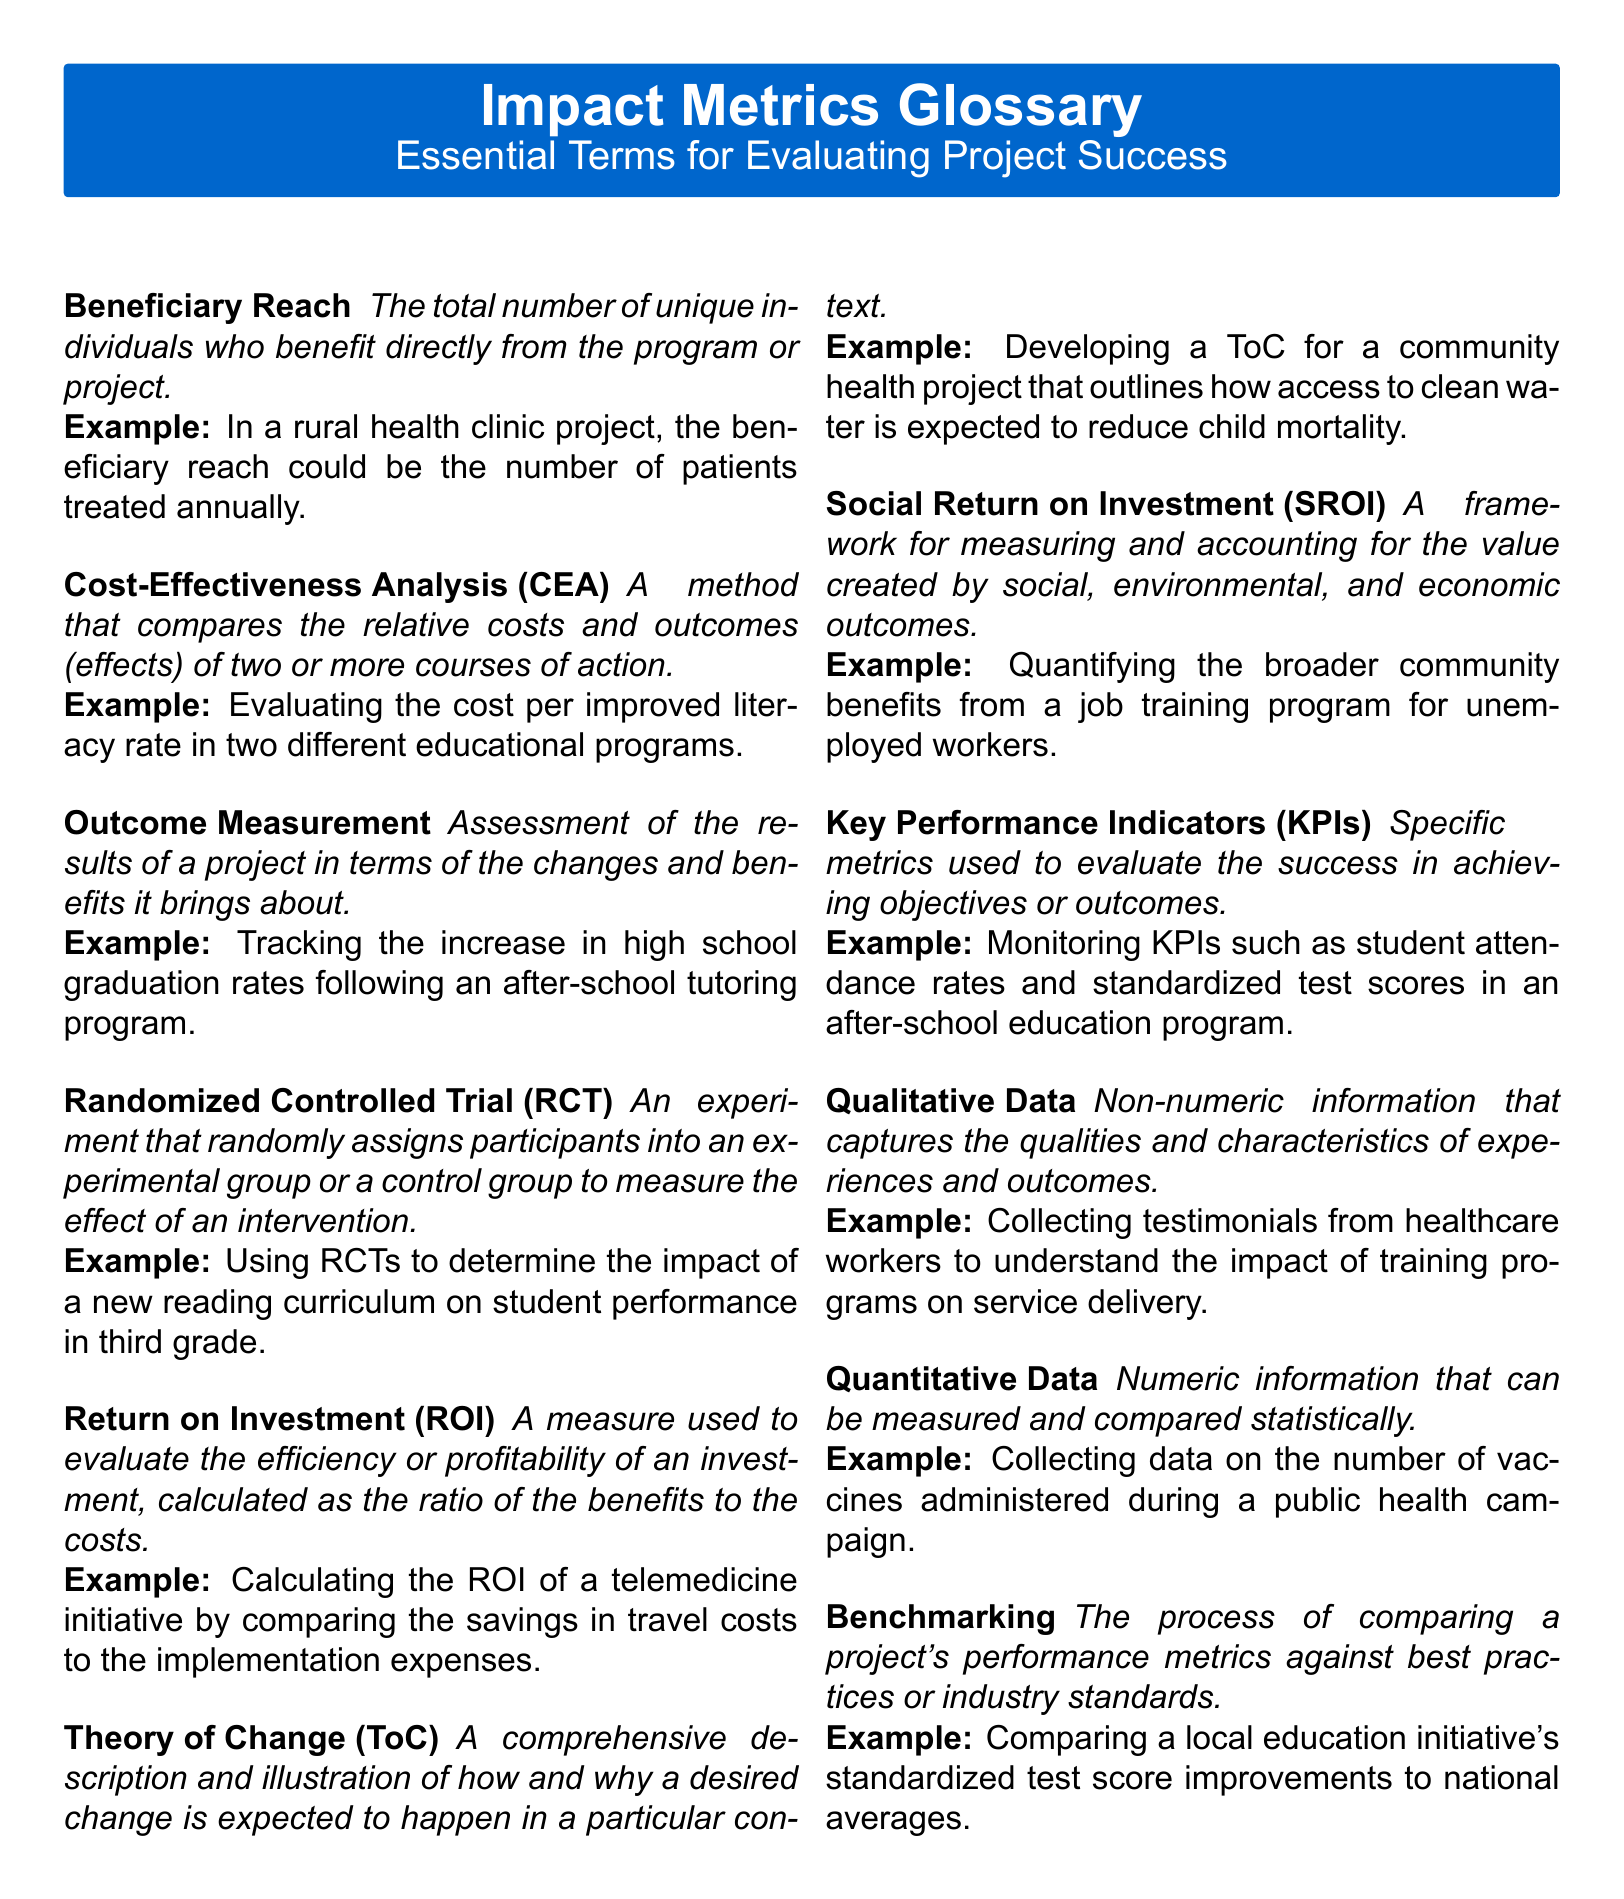What is the definition of Beneficiary Reach? Beneficiary Reach is defined as the total number of unique individuals who benefit directly from the program or project.
Answer: The total number of unique individuals who benefit directly from the program or project What does Cost-Effectiveness Analysis compare? Cost-Effectiveness Analysis compares the relative costs and outcomes of two or more courses of action.
Answer: The relative costs and outcomes of two or more courses of action What is an example of Outcome Measurement? An example provided is tracking the increase in high school graduation rates following an after-school tutoring program.
Answer: Tracking the increase in high school graduation rates following an after-school tutoring program What type of trial is a Randomized Controlled Trial? A Randomized Controlled Trial is a type of experiment that randomly assigns participants into an experimental group or a control group.
Answer: An experiment that randomly assigns participants into an experimental group or a control group What does ROI stand for? ROI stands for Return on Investment.
Answer: Return on Investment What is the purpose of Theory of Change? The purpose of Theory of Change is to illustrate how and why a desired change is expected to happen in a particular context.
Answer: To illustrate how and why a desired change is expected to happen in a particular context How are Key Performance Indicators defined? Key Performance Indicators are defined as specific metrics used to evaluate success in achieving objectives or outcomes.
Answer: Specific metrics used to evaluate the success in achieving objectives or outcomes What type of data is described as non-numeric? The type of data described as non-numeric is Qualitative Data.
Answer: Qualitative Data What does Benchmarking involve? Benchmarking involves comparing a project's performance metrics against best practices or industry standards.
Answer: Comparing a project's performance metrics against best practices or industry standards 